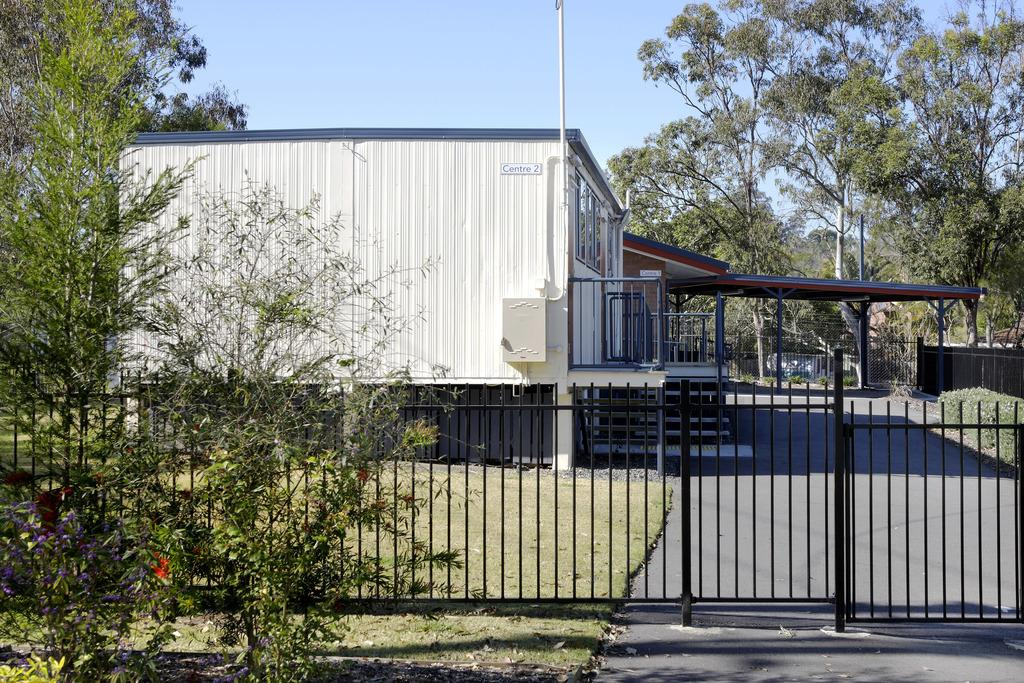What is the color of the house in the image? The house in the image is white. What structures can be seen in the image besides the house? There are poles in the image. What type of vegetation is present in the image? There are trees in the image, and grass is visible. What can be seen in the background of the image? The sky is visible in the background of the image. What type of development is the rat offering in the image? There is no rat or development present in the image. 